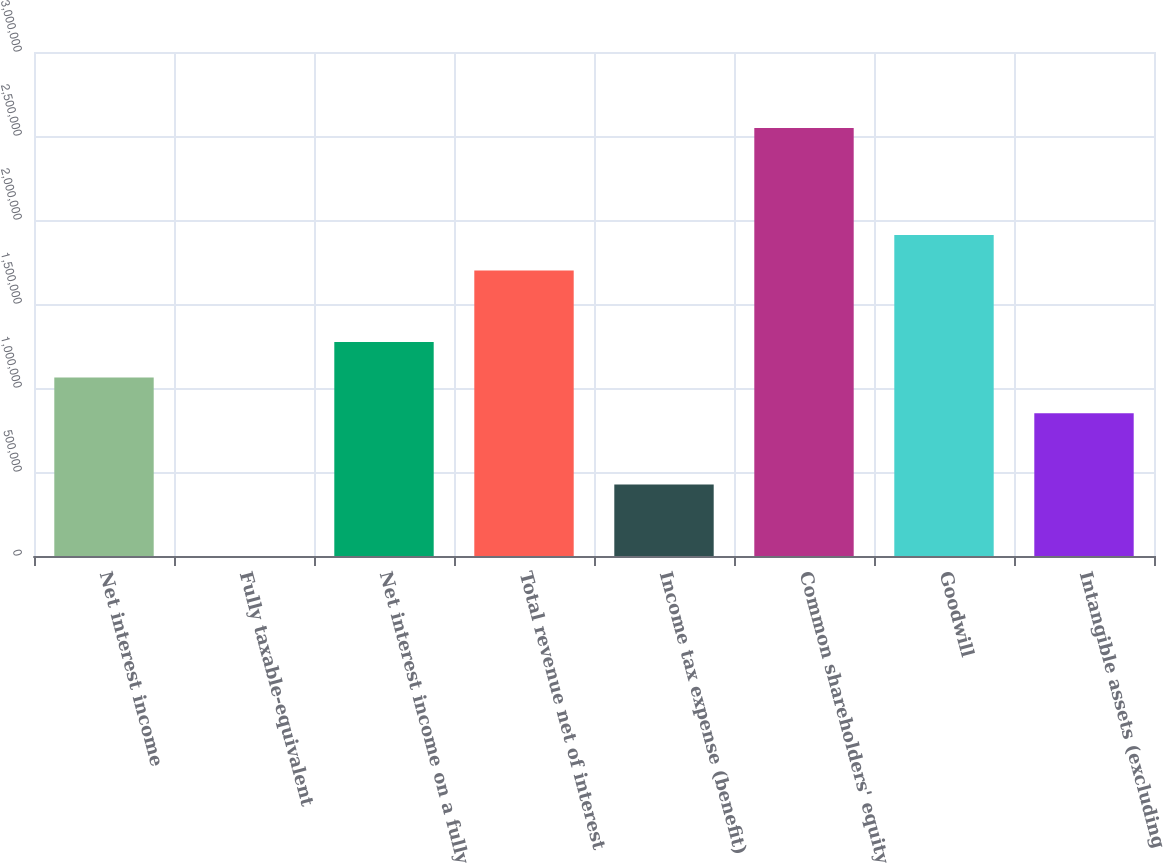<chart> <loc_0><loc_0><loc_500><loc_500><bar_chart><fcel>Net interest income<fcel>Fully taxable-equivalent<fcel>Net interest income on a fully<fcel>Total revenue net of interest<fcel>Income tax expense (benefit)<fcel>Common shareholders' equity<fcel>Goodwill<fcel>Intangible assets (excluding<nl><fcel>1.06192e+06<fcel>225<fcel>1.27426e+06<fcel>1.69894e+06<fcel>424903<fcel>2.54829e+06<fcel>1.91127e+06<fcel>849580<nl></chart> 